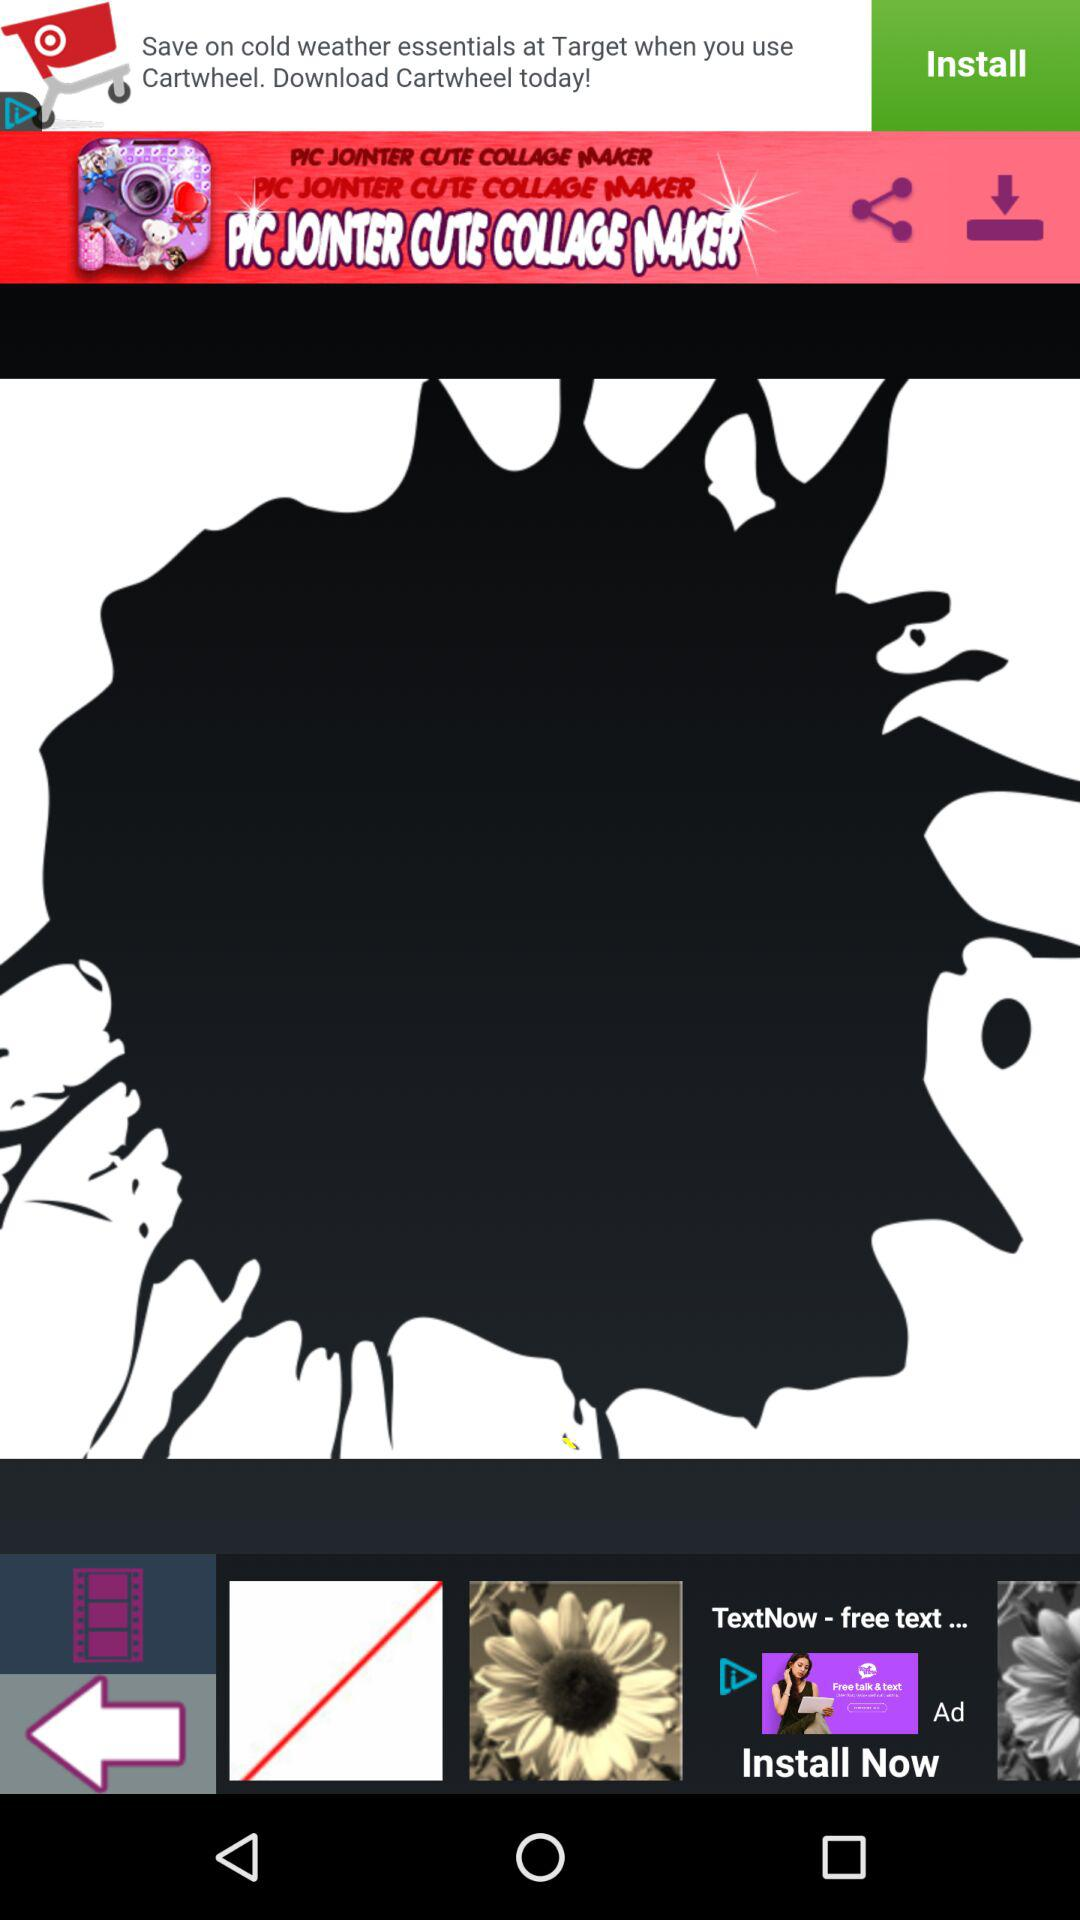What is the application name? The application name is "PIC JOINTER CUTE COLLAGE MAKER". 